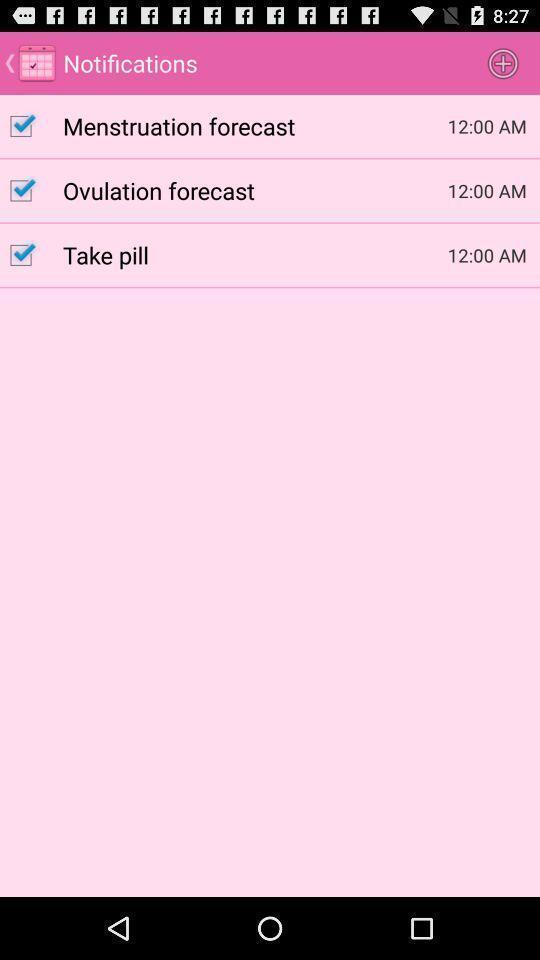Summarize the main components in this picture. Screen displaying the notifications page. 